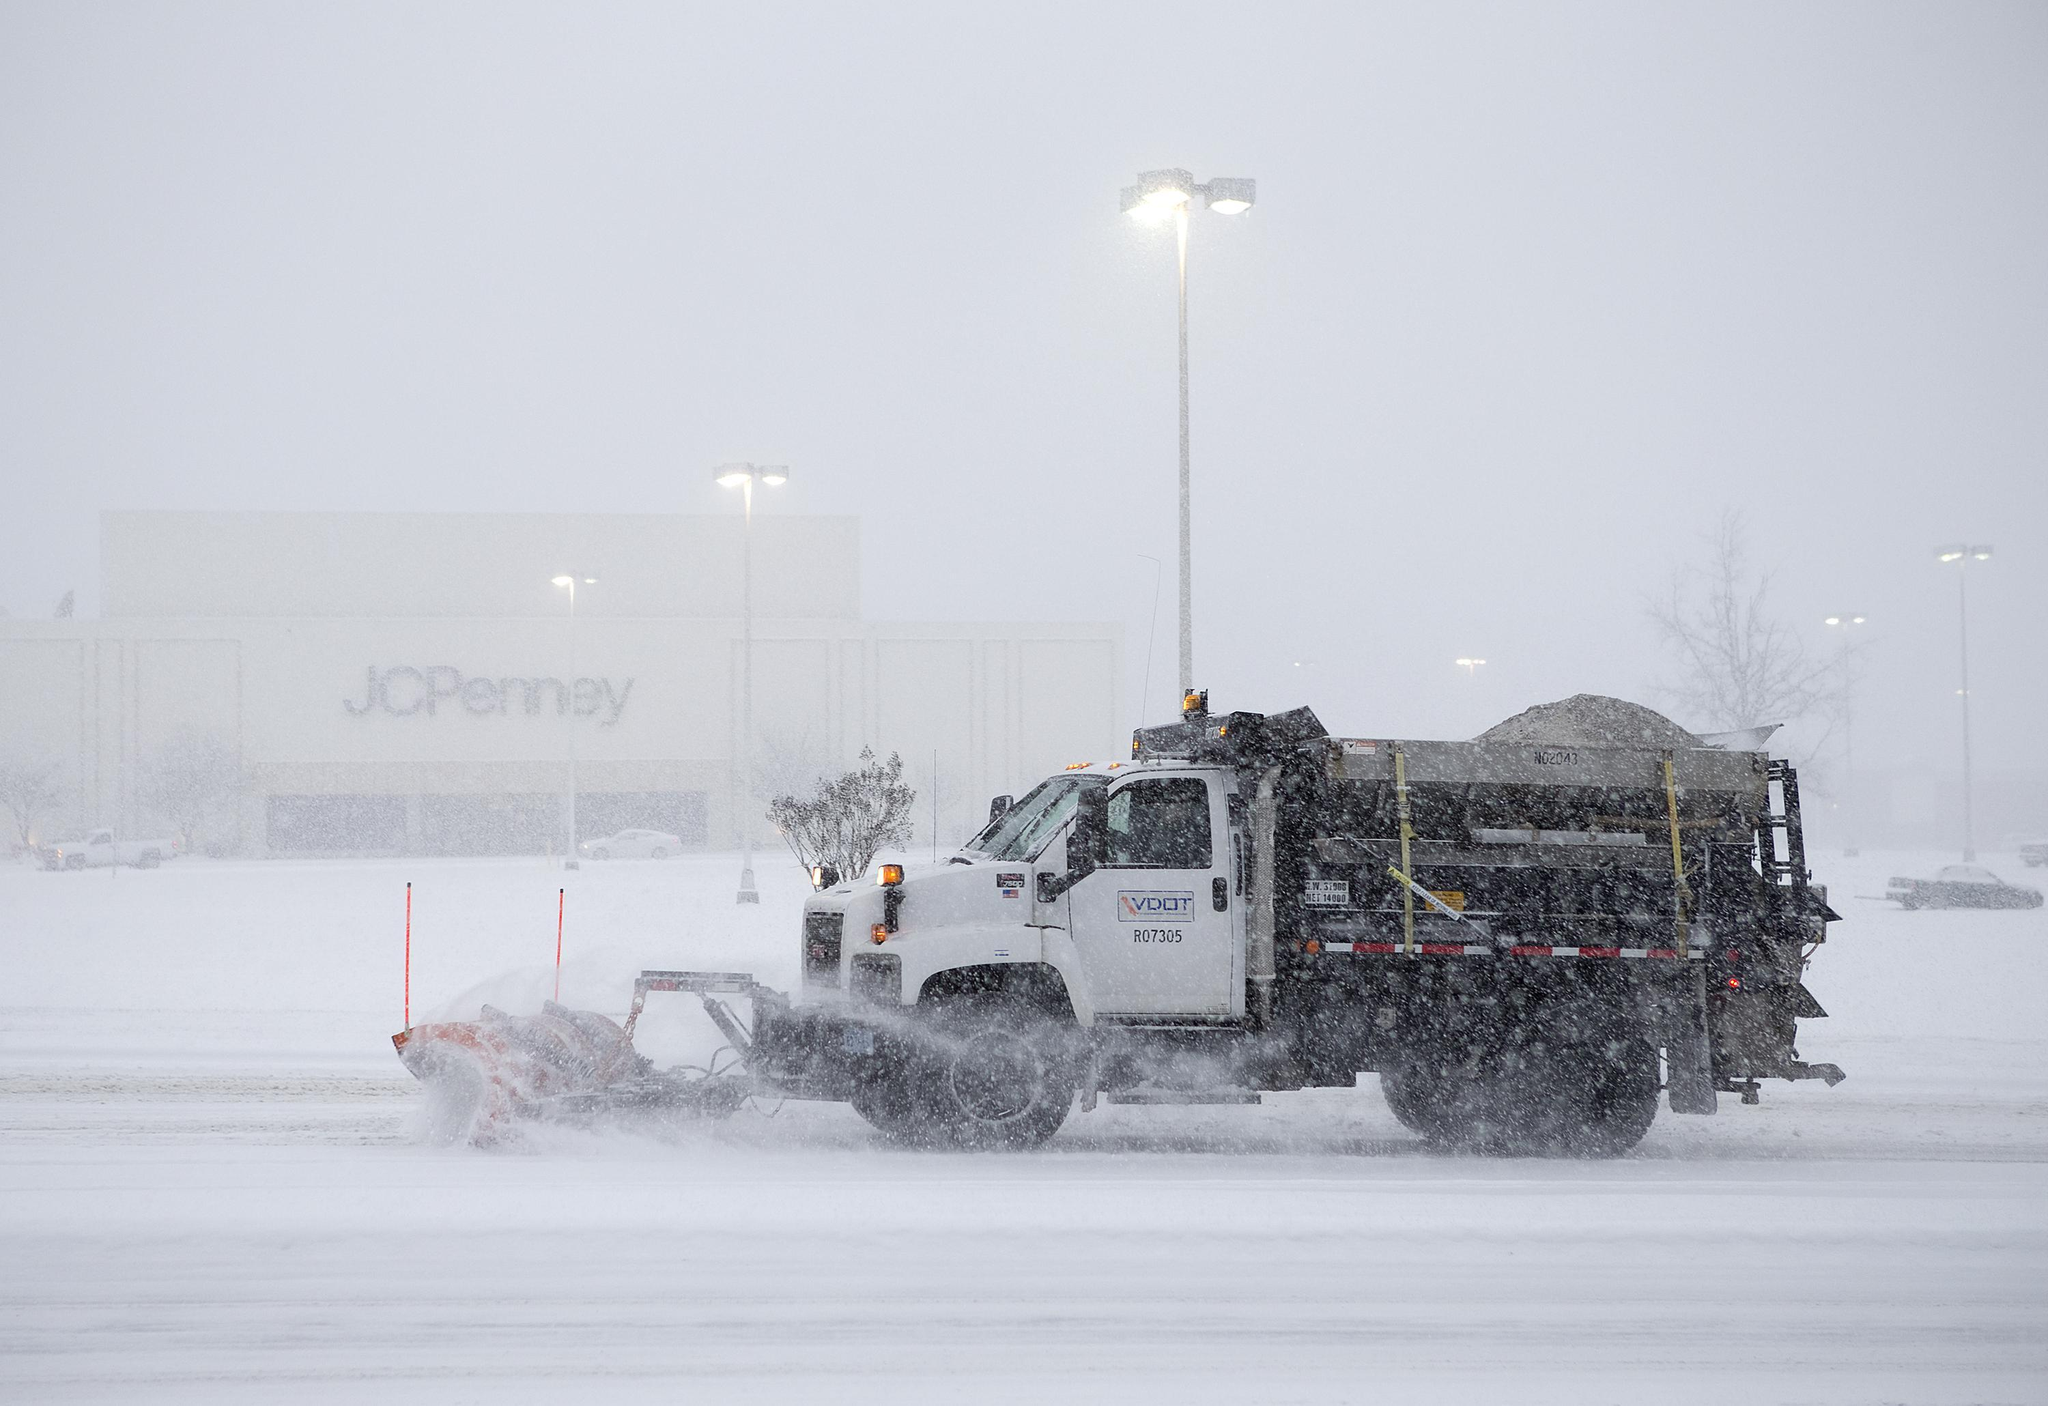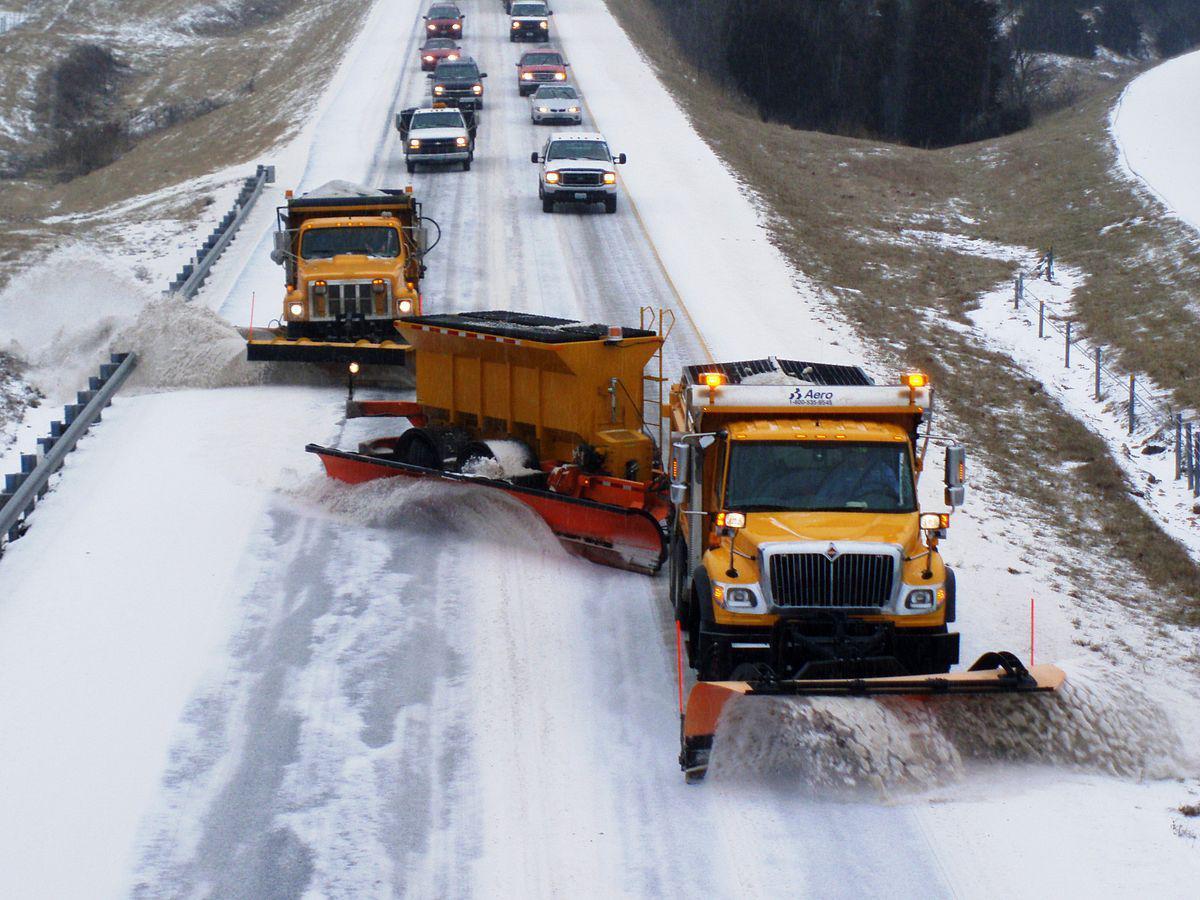The first image is the image on the left, the second image is the image on the right. For the images shown, is this caption "One of the images shows two plows and the other shows only one plow." true? Answer yes or no. Yes. The first image is the image on the left, the second image is the image on the right. Examine the images to the left and right. Is the description "The left and right image contains a total of three trucks." accurate? Answer yes or no. No. 